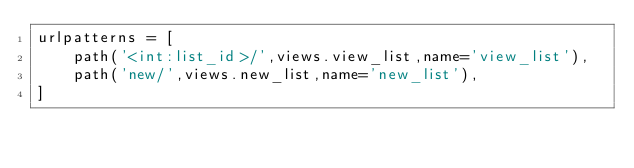<code> <loc_0><loc_0><loc_500><loc_500><_Python_>urlpatterns = [
    path('<int:list_id>/',views.view_list,name='view_list'),
    path('new/',views.new_list,name='new_list'),
]
</code> 